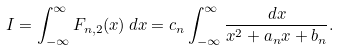Convert formula to latex. <formula><loc_0><loc_0><loc_500><loc_500>I = \int _ { - \infty } ^ { \infty } F _ { n , 2 } ( x ) \, d x = c _ { n } \int _ { - \infty } ^ { \infty } \frac { d x } { x ^ { 2 } + a _ { n } x + b _ { n } } .</formula> 